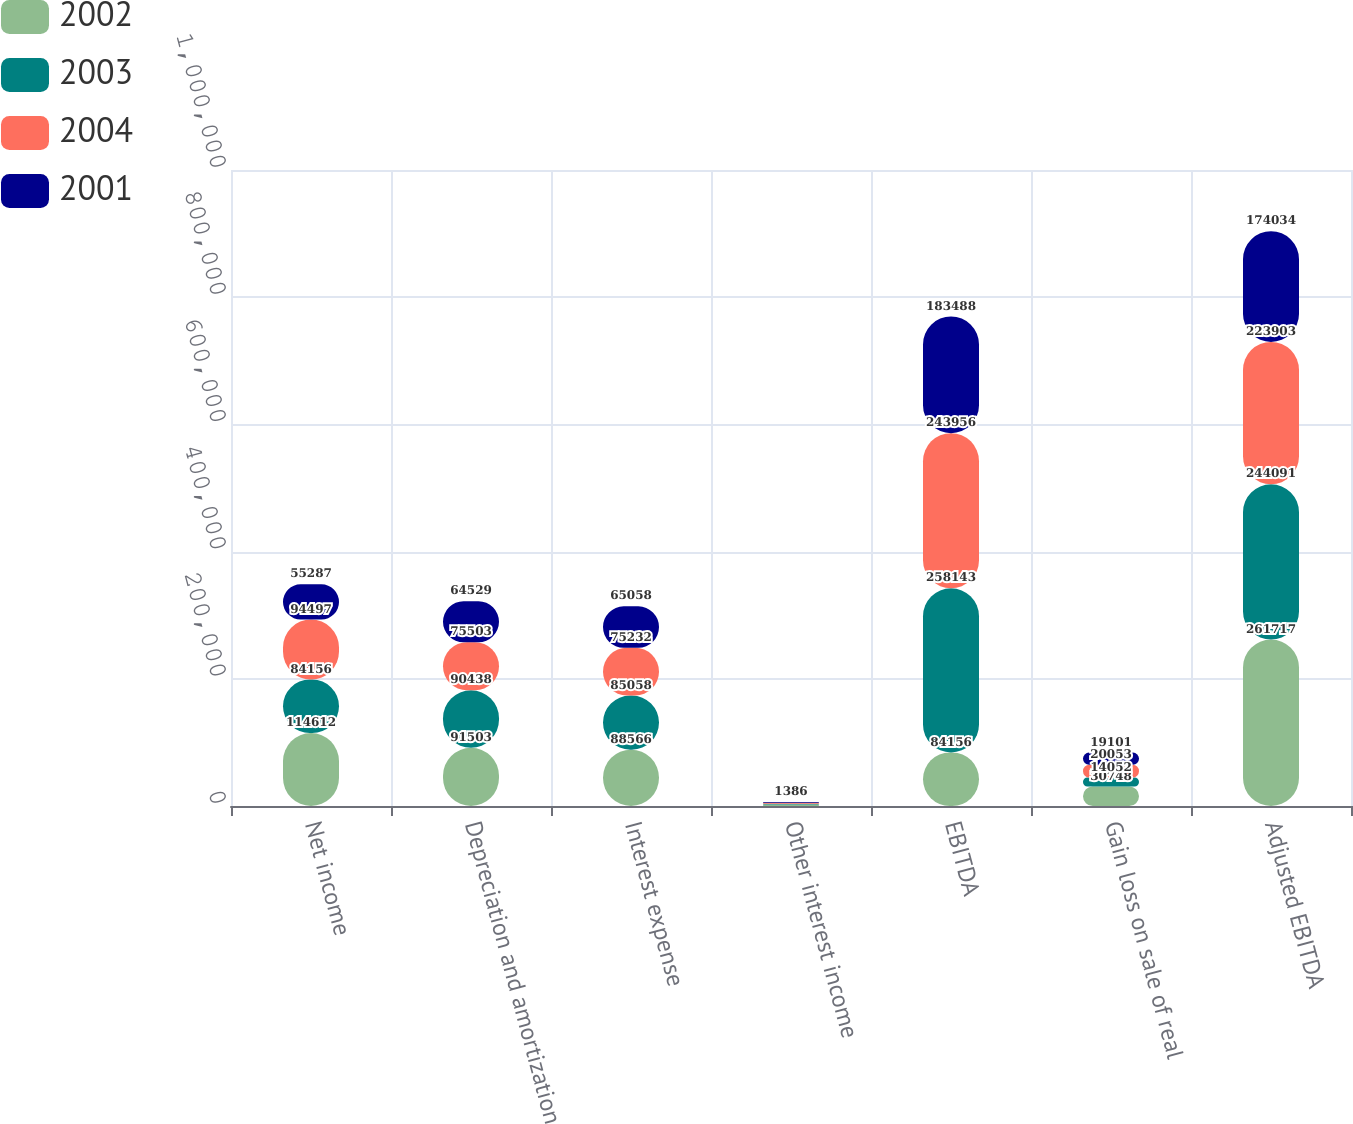<chart> <loc_0><loc_0><loc_500><loc_500><stacked_bar_chart><ecel><fcel>Net income<fcel>Depreciation and amortization<fcel>Interest expense<fcel>Other interest income<fcel>EBITDA<fcel>Gain loss on sale of real<fcel>Adjusted EBITDA<nl><fcel>2002<fcel>114612<fcel>91503<fcel>88566<fcel>2216<fcel>84156<fcel>30748<fcel>261717<nl><fcel>2003<fcel>84156<fcel>90438<fcel>85058<fcel>1509<fcel>258143<fcel>14052<fcel>244091<nl><fcel>2004<fcel>94497<fcel>75503<fcel>75232<fcel>1276<fcel>243956<fcel>20053<fcel>223903<nl><fcel>2001<fcel>55287<fcel>64529<fcel>65058<fcel>1386<fcel>183488<fcel>19101<fcel>174034<nl></chart> 